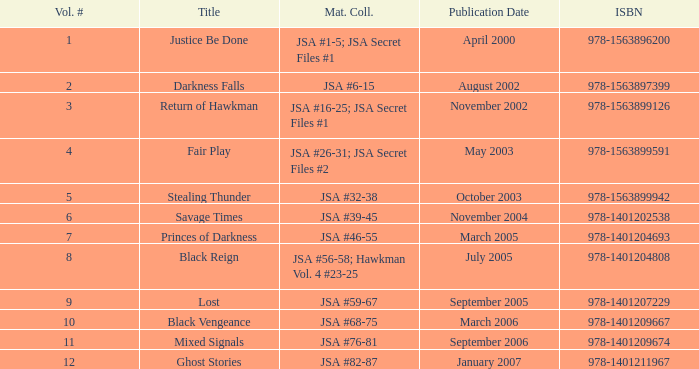Which material is associated with the isbn 978-1401209674? JSA #76-81. 